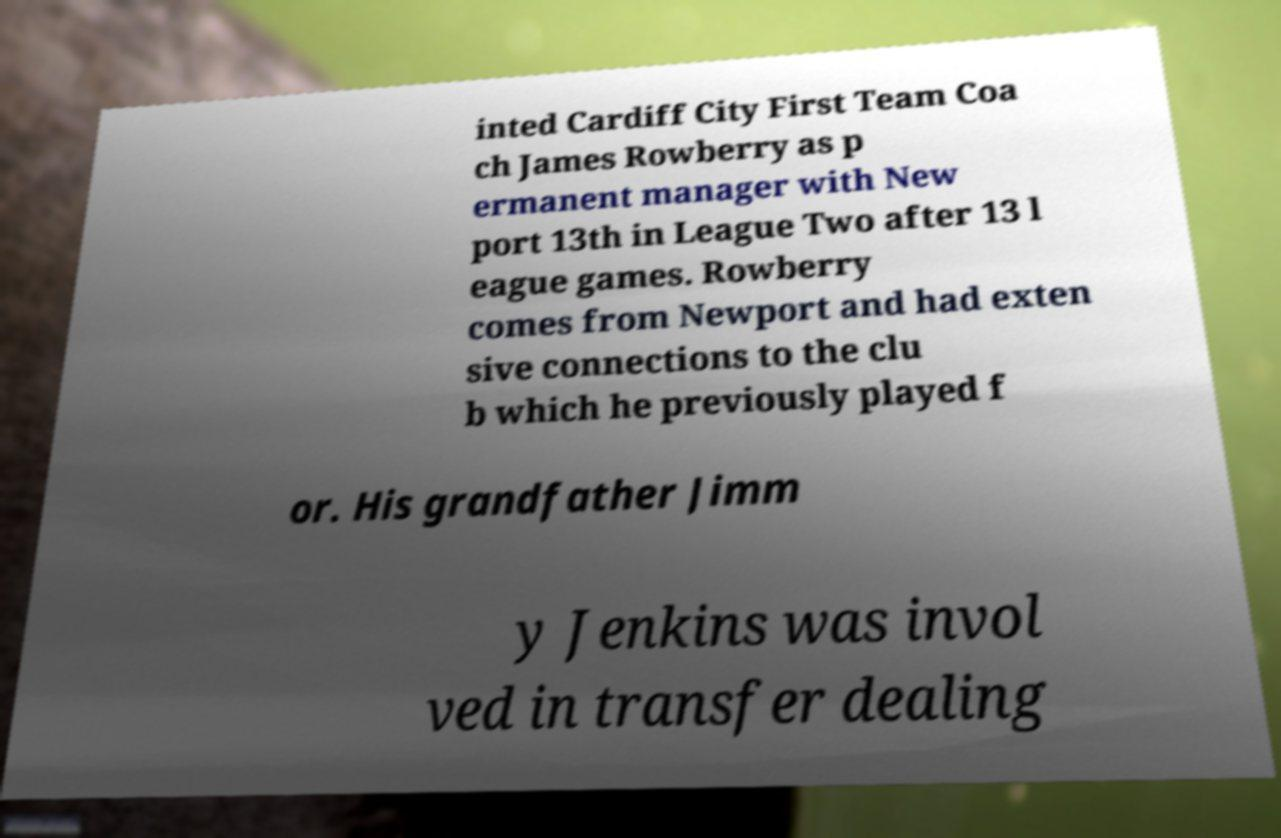Could you extract and type out the text from this image? inted Cardiff City First Team Coa ch James Rowberry as p ermanent manager with New port 13th in League Two after 13 l eague games. Rowberry comes from Newport and had exten sive connections to the clu b which he previously played f or. His grandfather Jimm y Jenkins was invol ved in transfer dealing 